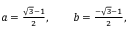Convert formula to latex. <formula><loc_0><loc_0><loc_500><loc_500>\begin{array} { r } { a = \frac { \sqrt { 3 } - 1 } { 2 } , \quad b = \frac { - \sqrt { 3 } - 1 } { 2 } , } \end{array}</formula> 